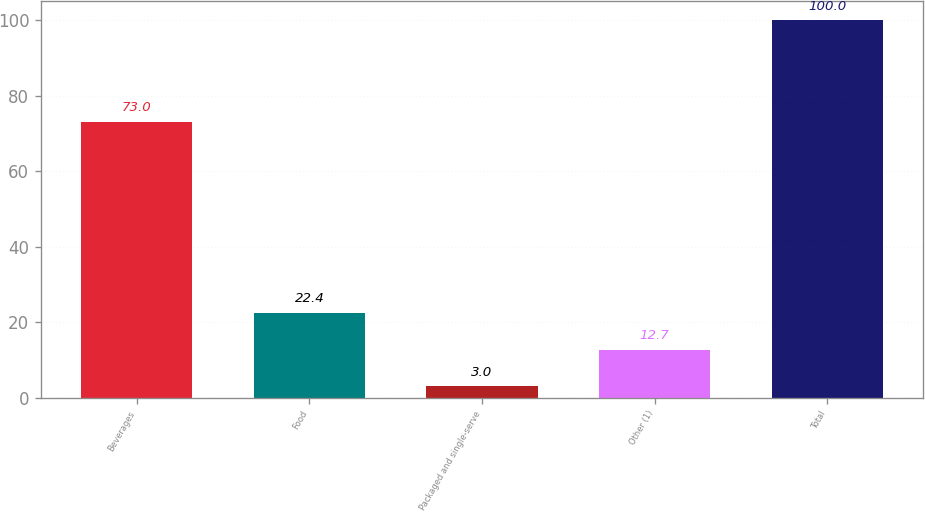Convert chart. <chart><loc_0><loc_0><loc_500><loc_500><bar_chart><fcel>Beverages<fcel>Food<fcel>Packaged and single-serve<fcel>Other (1)<fcel>Total<nl><fcel>73<fcel>22.4<fcel>3<fcel>12.7<fcel>100<nl></chart> 